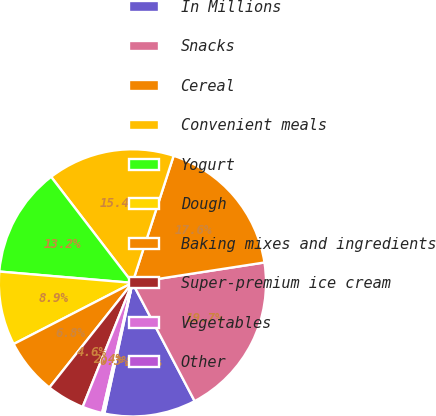<chart> <loc_0><loc_0><loc_500><loc_500><pie_chart><fcel>In Millions<fcel>Snacks<fcel>Cereal<fcel>Convenient meals<fcel>Yogurt<fcel>Dough<fcel>Baking mixes and ingredients<fcel>Super-premium ice cream<fcel>Vegetables<fcel>Other<nl><fcel>11.08%<fcel>19.73%<fcel>17.57%<fcel>15.4%<fcel>13.24%<fcel>8.92%<fcel>6.76%<fcel>4.6%<fcel>2.43%<fcel>0.27%<nl></chart> 